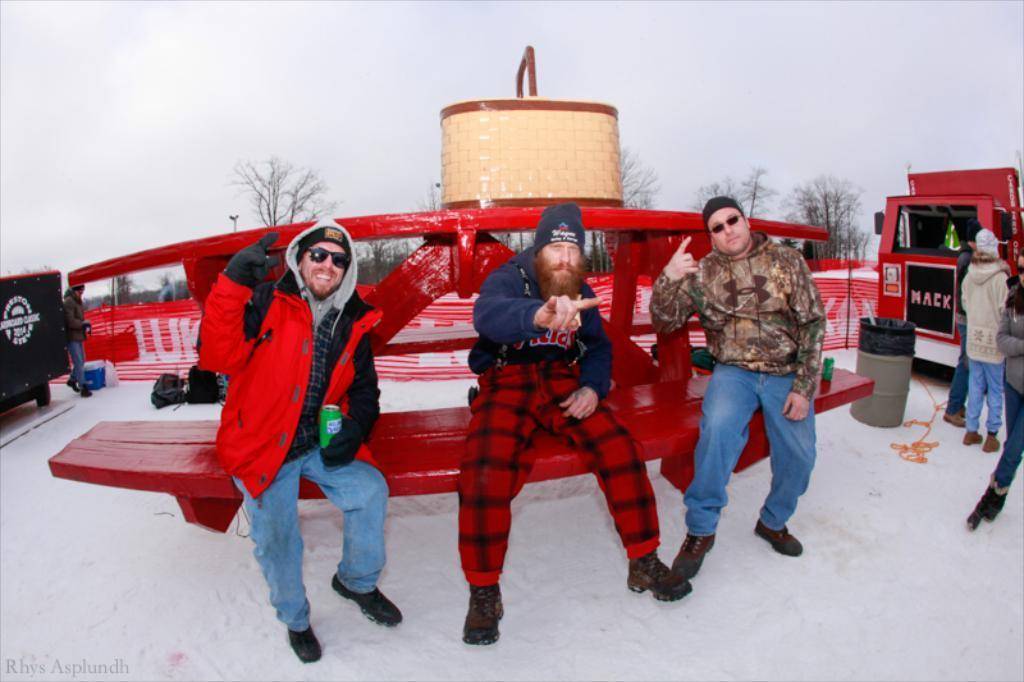How would you summarize this image in a sentence or two? In the image,there is a land covered with a lot of snow,on the snow there is a bench and there are three men sitting on the bench and posing,beside the bench there is some vehicle and in front of the vehicle there are few other people standing,in the background there are some dry trees. 